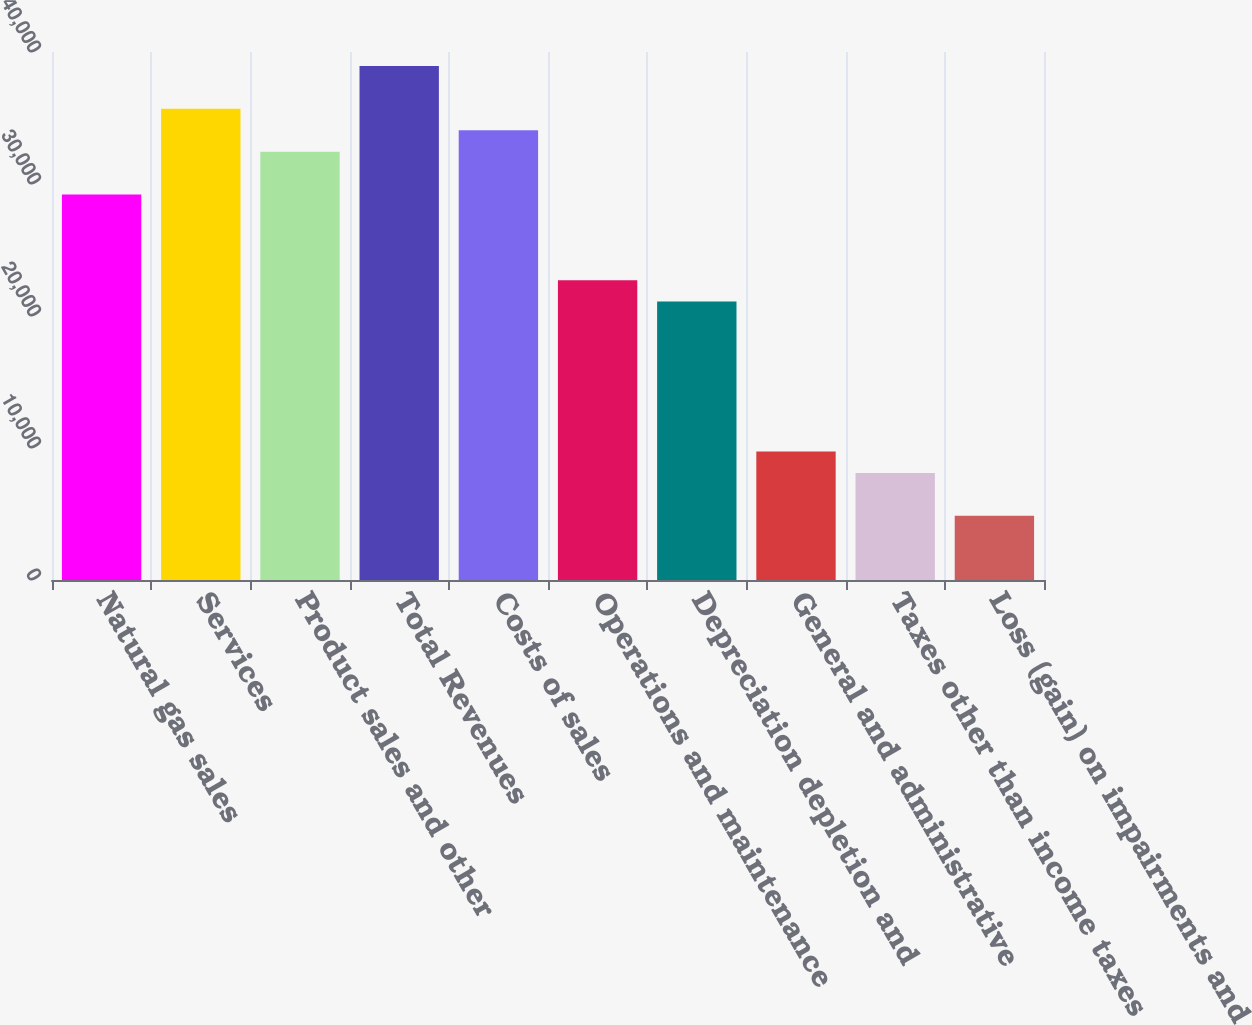Convert chart to OTSL. <chart><loc_0><loc_0><loc_500><loc_500><bar_chart><fcel>Natural gas sales<fcel>Services<fcel>Product sales and other<fcel>Total Revenues<fcel>Costs of sales<fcel>Operations and maintenance<fcel>Depreciation depletion and<fcel>General and administrative<fcel>Taxes other than income taxes<fcel>Loss (gain) on impairments and<nl><fcel>29206<fcel>35696<fcel>32451<fcel>38941<fcel>34073.5<fcel>22716<fcel>21093.5<fcel>9736<fcel>8113.5<fcel>4868.5<nl></chart> 